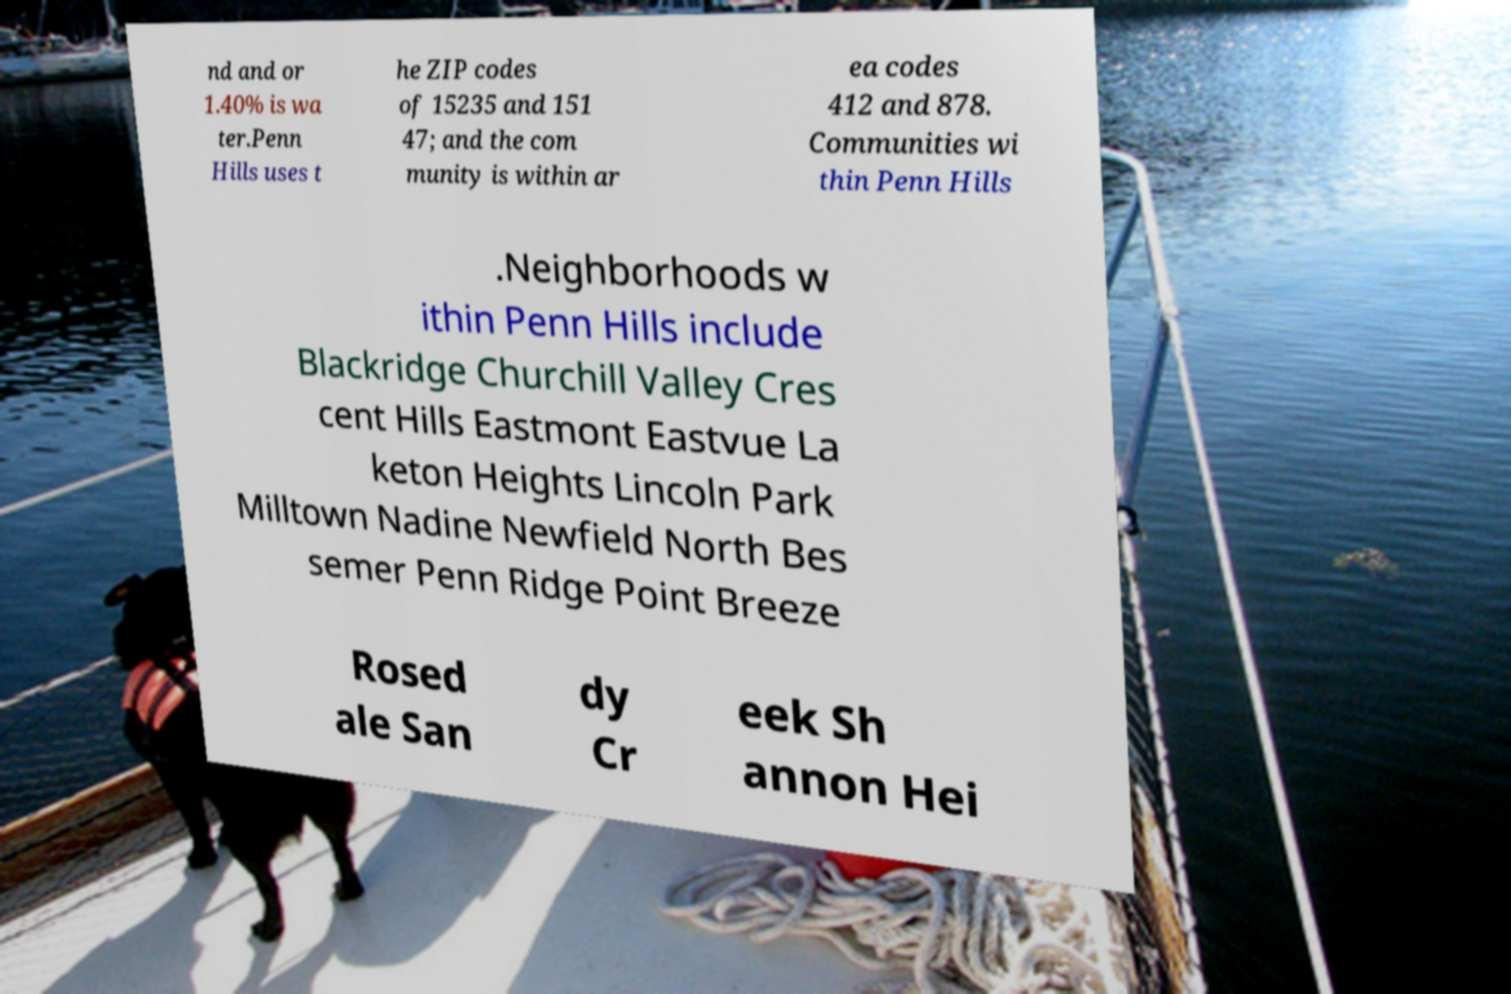Could you extract and type out the text from this image? nd and or 1.40% is wa ter.Penn Hills uses t he ZIP codes of 15235 and 151 47; and the com munity is within ar ea codes 412 and 878. Communities wi thin Penn Hills .Neighborhoods w ithin Penn Hills include Blackridge Churchill Valley Cres cent Hills Eastmont Eastvue La keton Heights Lincoln Park Milltown Nadine Newfield North Bes semer Penn Ridge Point Breeze Rosed ale San dy Cr eek Sh annon Hei 